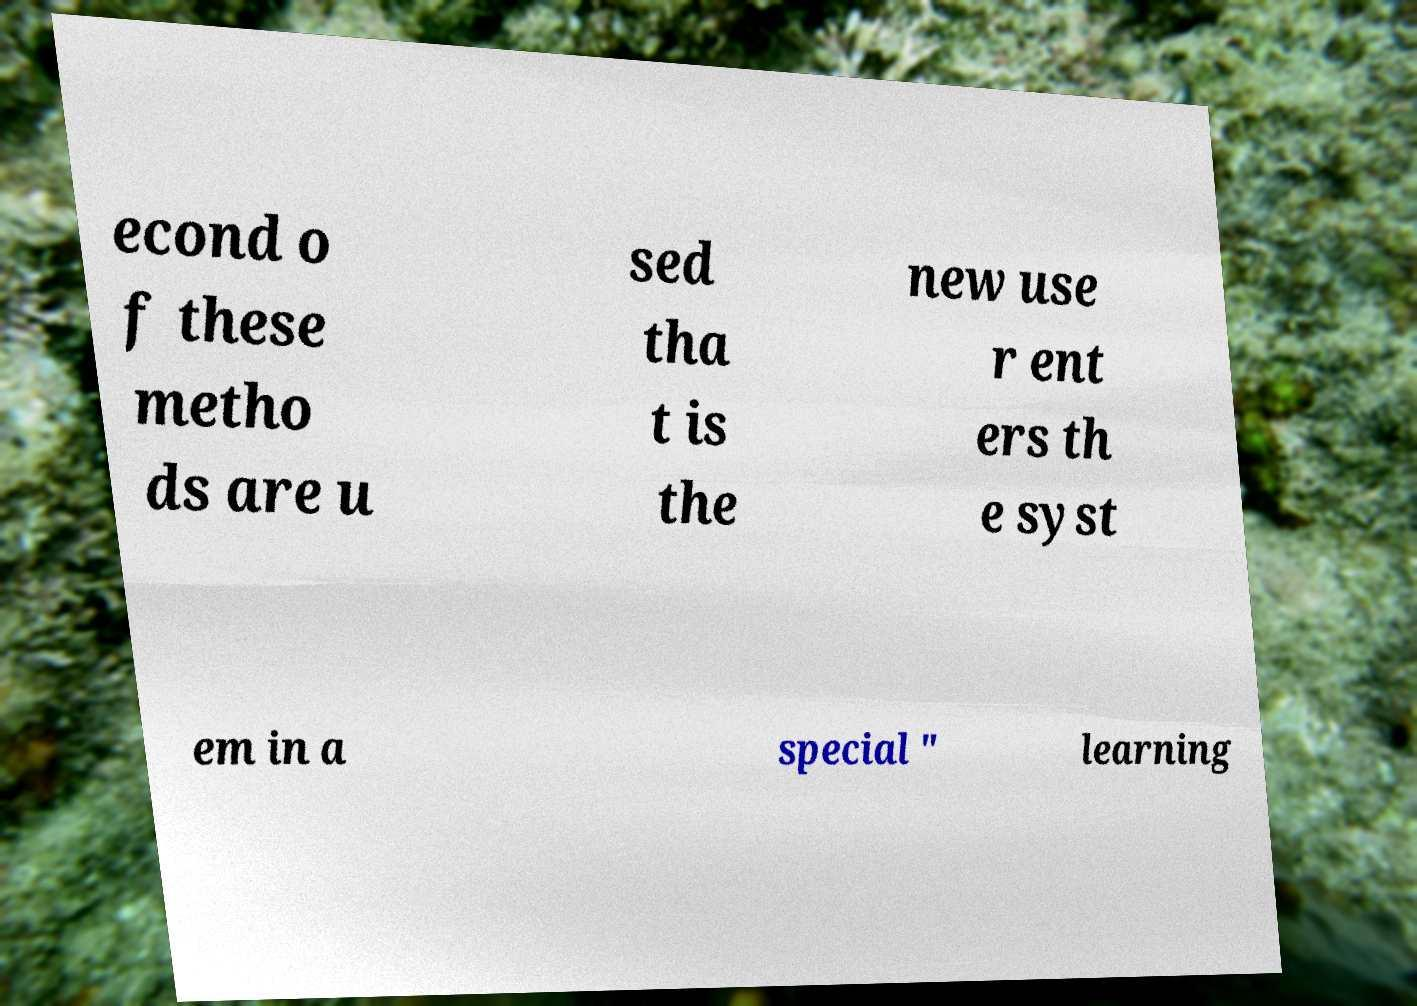I need the written content from this picture converted into text. Can you do that? econd o f these metho ds are u sed tha t is the new use r ent ers th e syst em in a special " learning 